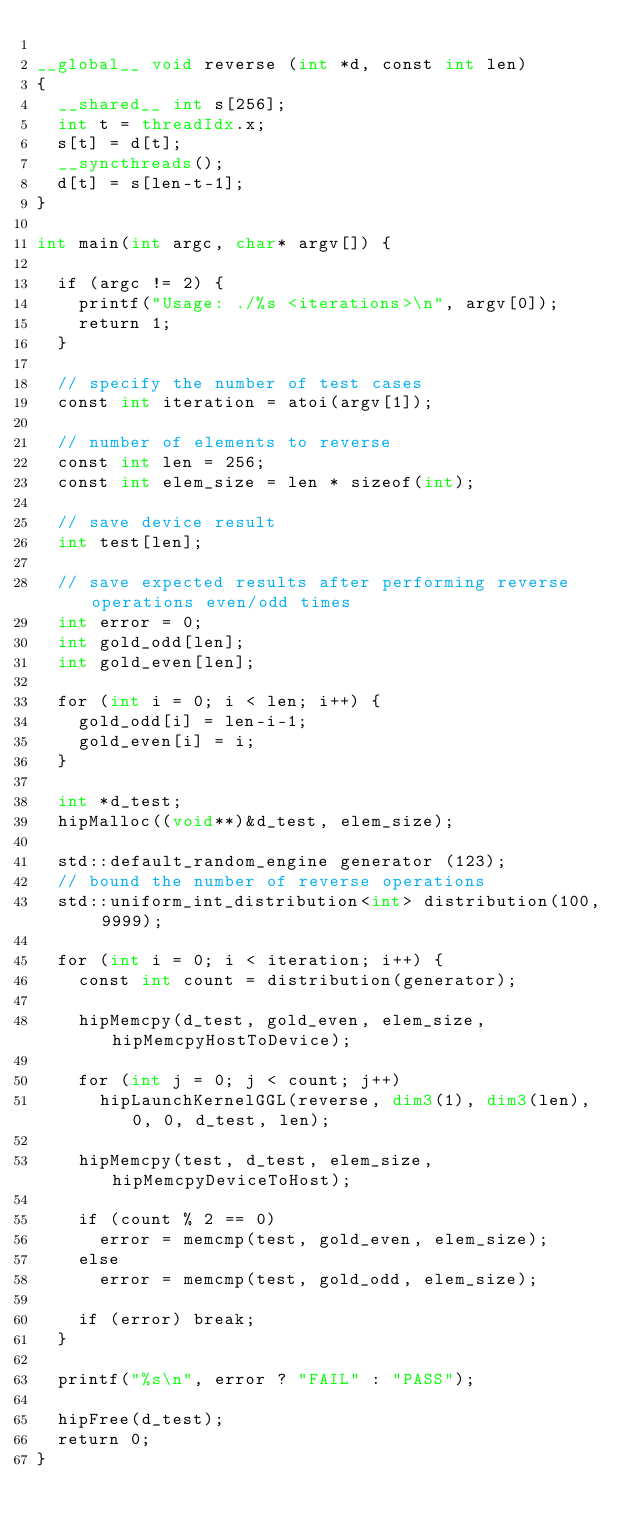<code> <loc_0><loc_0><loc_500><loc_500><_Cuda_>
__global__ void reverse (int *d, const int len)
{
  __shared__ int s[256];
  int t = threadIdx.x;
  s[t] = d[t];
  __syncthreads();
  d[t] = s[len-t-1];
}

int main(int argc, char* argv[]) {

  if (argc != 2) {
    printf("Usage: ./%s <iterations>\n", argv[0]);
    return 1;
  }

  // specify the number of test cases
  const int iteration = atoi(argv[1]);

  // number of elements to reverse
  const int len = 256;
  const int elem_size = len * sizeof(int);

  // save device result
  int test[len];

  // save expected results after performing reverse operations even/odd times
  int error = 0;
  int gold_odd[len];
  int gold_even[len];

  for (int i = 0; i < len; i++) {
    gold_odd[i] = len-i-1;
    gold_even[i] = i;
  }

  int *d_test;
  hipMalloc((void**)&d_test, elem_size);

  std::default_random_engine generator (123);
  // bound the number of reverse operations
  std::uniform_int_distribution<int> distribution(100, 9999);

  for (int i = 0; i < iteration; i++) {
    const int count = distribution(generator);

    hipMemcpy(d_test, gold_even, elem_size, hipMemcpyHostToDevice);

    for (int j = 0; j < count; j++)
      hipLaunchKernelGGL(reverse, dim3(1), dim3(len), 0, 0, d_test, len);

    hipMemcpy(test, d_test, elem_size, hipMemcpyDeviceToHost);

    if (count % 2 == 0)
      error = memcmp(test, gold_even, elem_size);
    else
      error = memcmp(test, gold_odd, elem_size);
    
    if (error) break;
  }
  
  printf("%s\n", error ? "FAIL" : "PASS");

  hipFree(d_test);
  return 0;
}
</code> 